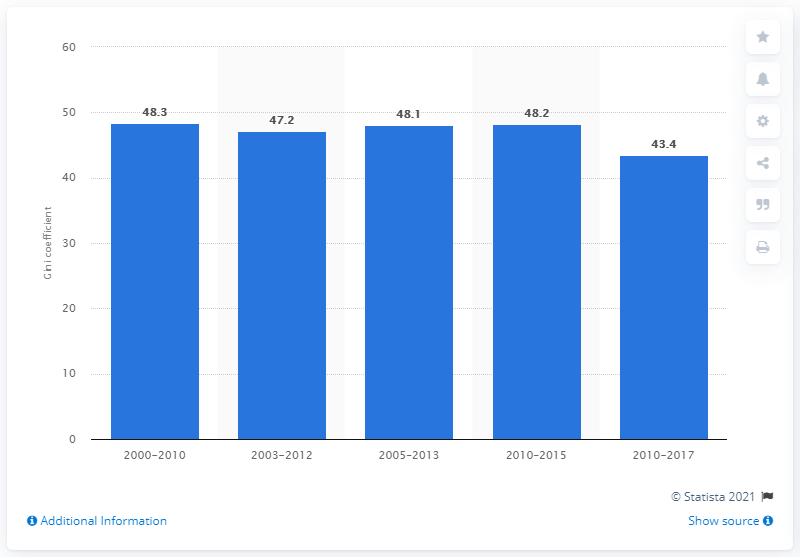List a handful of essential elements in this visual. The Gini coefficient is a measure that assesses the deviation of the distribution of income among individuals or households in a given country from a perfectly equal distribution. The Gini coefficient in Mexico in 2017 was 43.4, which indicates a high level of income inequality in the country. 